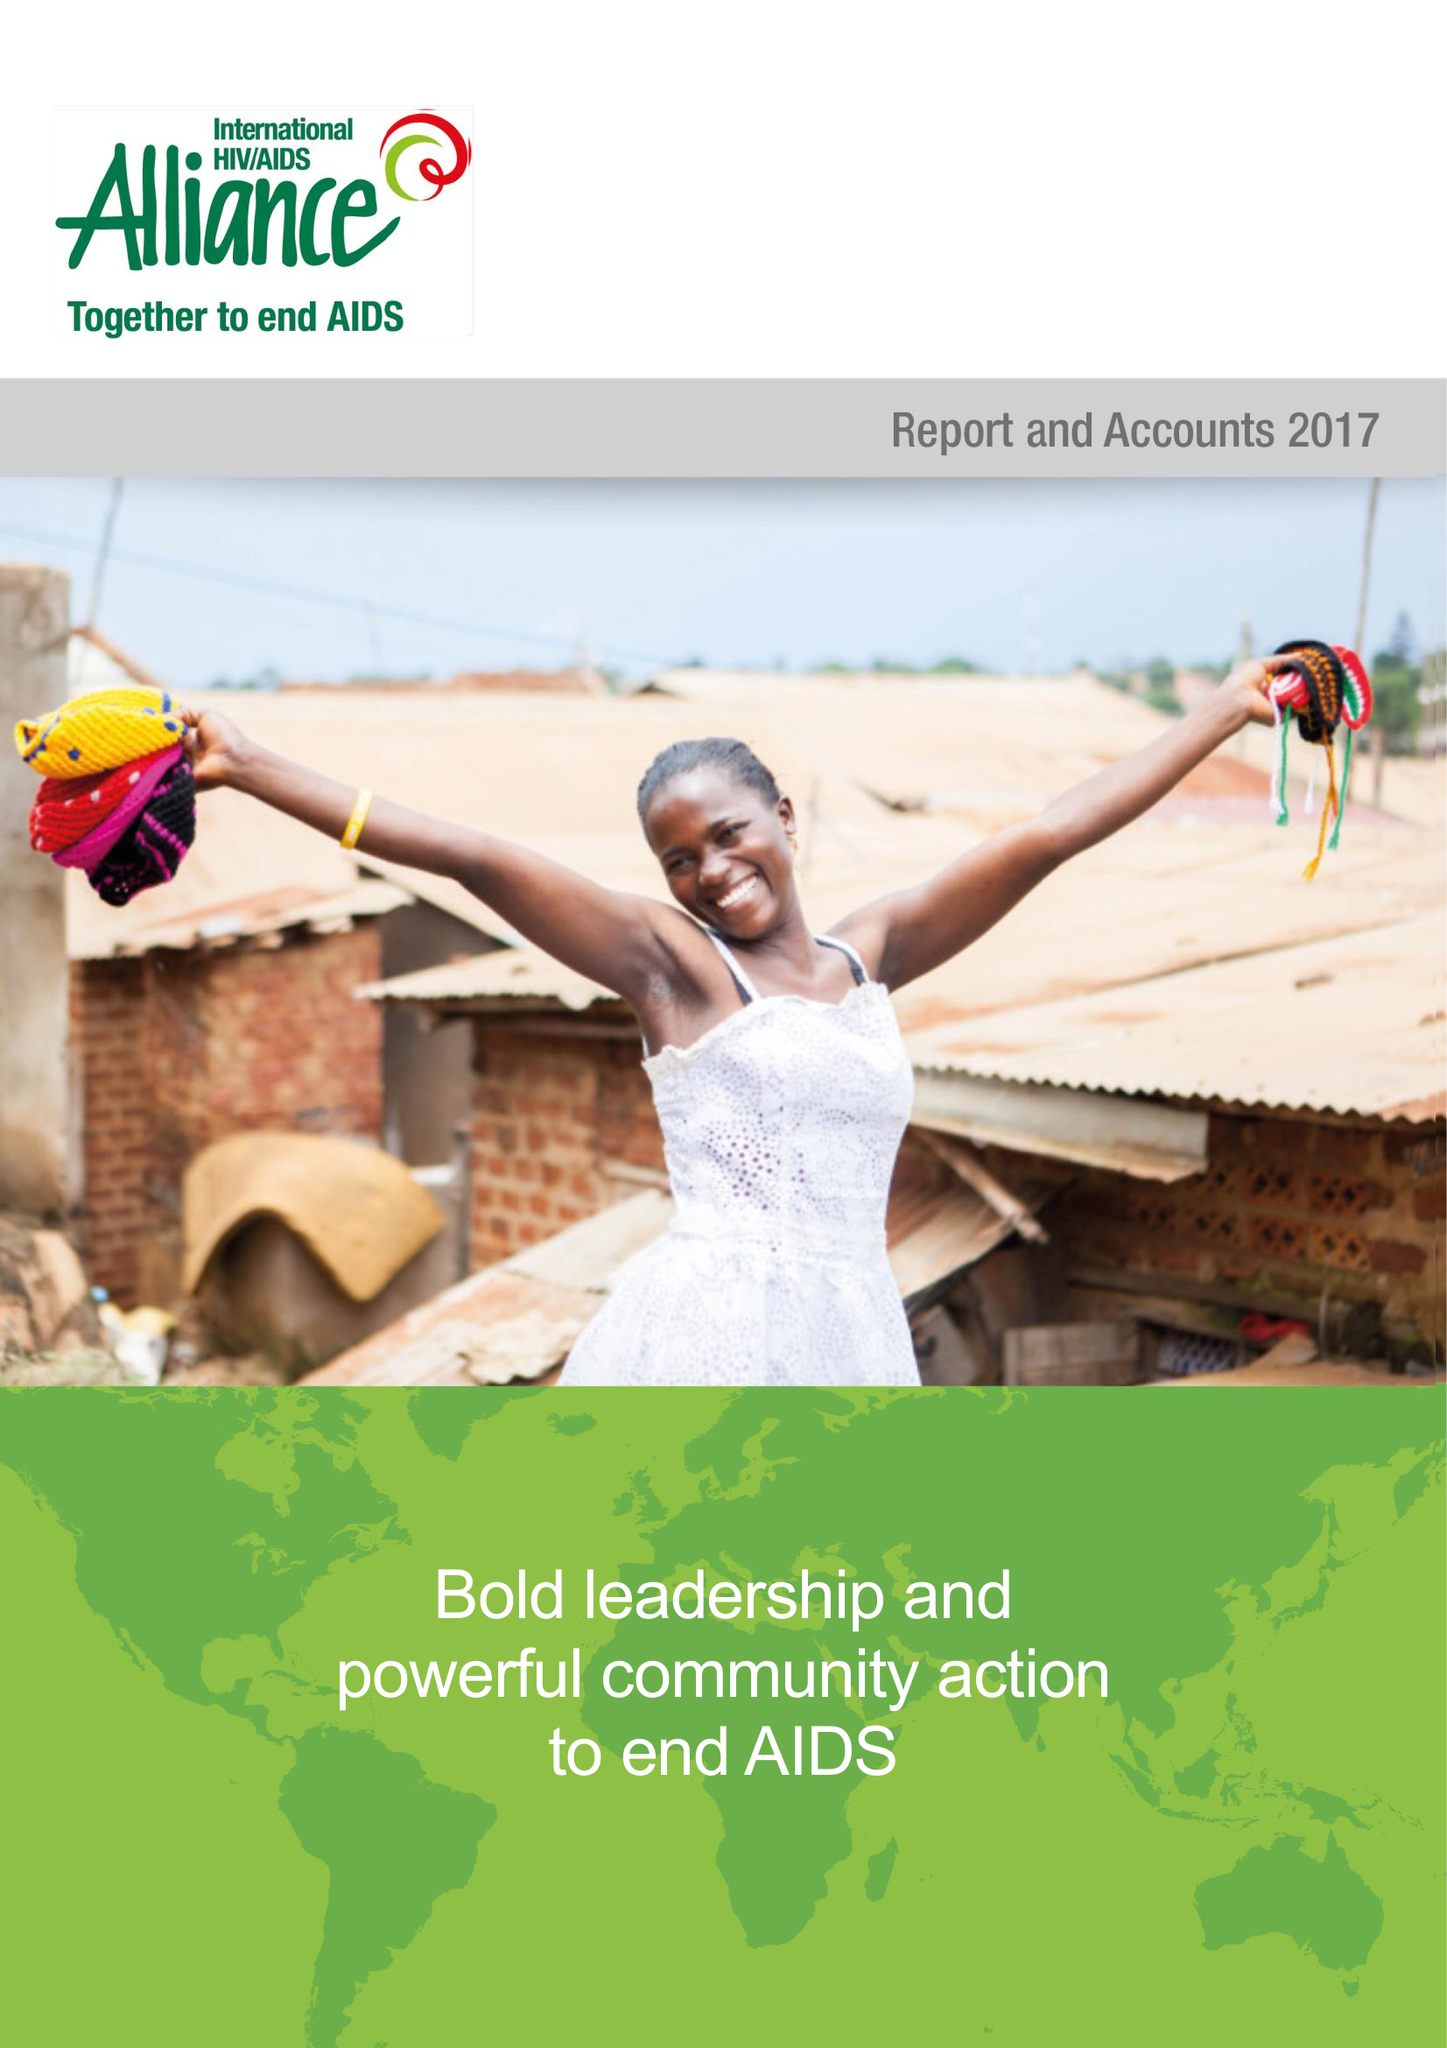What is the value for the charity_number?
Answer the question using a single word or phrase. 1038860 